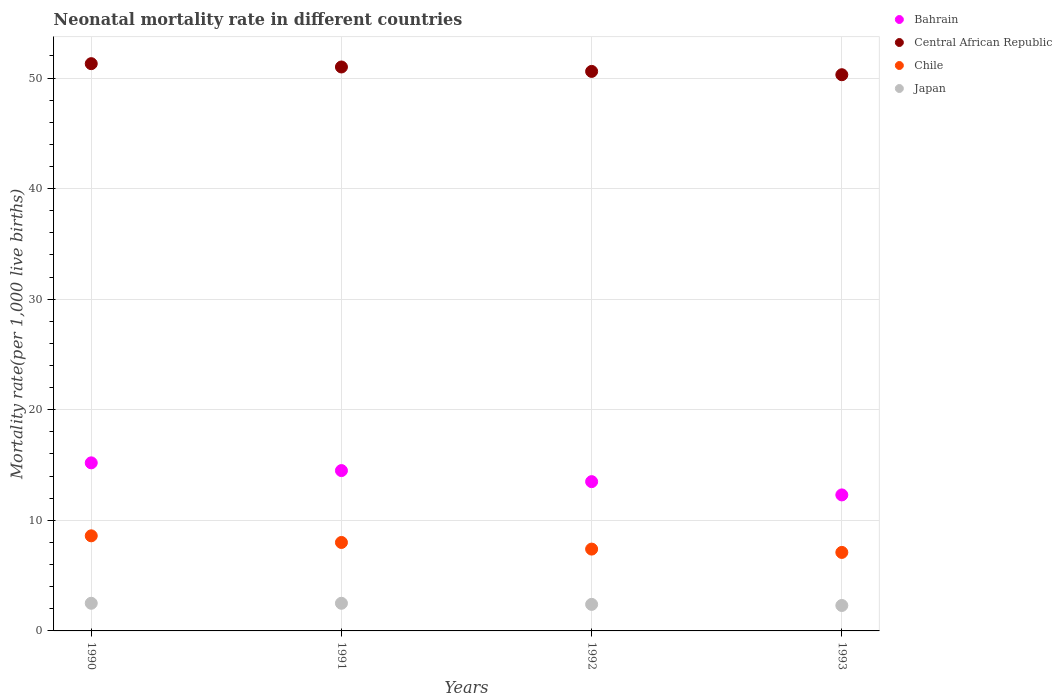How many different coloured dotlines are there?
Ensure brevity in your answer.  4. Is the number of dotlines equal to the number of legend labels?
Ensure brevity in your answer.  Yes. What is the neonatal mortality rate in Central African Republic in 1993?
Ensure brevity in your answer.  50.3. Across all years, what is the maximum neonatal mortality rate in Central African Republic?
Give a very brief answer. 51.3. Across all years, what is the minimum neonatal mortality rate in Japan?
Your response must be concise. 2.3. In which year was the neonatal mortality rate in Central African Republic maximum?
Provide a short and direct response. 1990. What is the total neonatal mortality rate in Bahrain in the graph?
Offer a terse response. 55.5. What is the difference between the neonatal mortality rate in Japan in 1992 and that in 1993?
Keep it short and to the point. 0.1. What is the difference between the neonatal mortality rate in Chile in 1993 and the neonatal mortality rate in Bahrain in 1992?
Give a very brief answer. -6.4. What is the average neonatal mortality rate in Chile per year?
Keep it short and to the point. 7.78. In how many years, is the neonatal mortality rate in Central African Republic greater than 40?
Your answer should be very brief. 4. What is the ratio of the neonatal mortality rate in Japan in 1992 to that in 1993?
Ensure brevity in your answer.  1.04. What is the difference between the highest and the lowest neonatal mortality rate in Central African Republic?
Give a very brief answer. 1. Is the sum of the neonatal mortality rate in Japan in 1991 and 1993 greater than the maximum neonatal mortality rate in Central African Republic across all years?
Make the answer very short. No. Does the neonatal mortality rate in Bahrain monotonically increase over the years?
Make the answer very short. No. Is the neonatal mortality rate in Chile strictly greater than the neonatal mortality rate in Central African Republic over the years?
Give a very brief answer. No. Is the neonatal mortality rate in Central African Republic strictly less than the neonatal mortality rate in Chile over the years?
Keep it short and to the point. No. How many dotlines are there?
Ensure brevity in your answer.  4. How many years are there in the graph?
Keep it short and to the point. 4. What is the difference between two consecutive major ticks on the Y-axis?
Your response must be concise. 10. Are the values on the major ticks of Y-axis written in scientific E-notation?
Your answer should be very brief. No. Does the graph contain any zero values?
Provide a succinct answer. No. How are the legend labels stacked?
Your answer should be very brief. Vertical. What is the title of the graph?
Your answer should be compact. Neonatal mortality rate in different countries. What is the label or title of the Y-axis?
Offer a terse response. Mortality rate(per 1,0 live births). What is the Mortality rate(per 1,000 live births) in Central African Republic in 1990?
Offer a terse response. 51.3. What is the Mortality rate(per 1,000 live births) in Chile in 1990?
Offer a very short reply. 8.6. What is the Mortality rate(per 1,000 live births) in Japan in 1990?
Keep it short and to the point. 2.5. What is the Mortality rate(per 1,000 live births) of Central African Republic in 1991?
Offer a terse response. 51. What is the Mortality rate(per 1,000 live births) in Chile in 1991?
Provide a short and direct response. 8. What is the Mortality rate(per 1,000 live births) in Japan in 1991?
Your answer should be compact. 2.5. What is the Mortality rate(per 1,000 live births) in Central African Republic in 1992?
Provide a short and direct response. 50.6. What is the Mortality rate(per 1,000 live births) in Bahrain in 1993?
Offer a very short reply. 12.3. What is the Mortality rate(per 1,000 live births) of Central African Republic in 1993?
Your answer should be very brief. 50.3. What is the Mortality rate(per 1,000 live births) in Japan in 1993?
Your answer should be compact. 2.3. Across all years, what is the maximum Mortality rate(per 1,000 live births) in Bahrain?
Offer a terse response. 15.2. Across all years, what is the maximum Mortality rate(per 1,000 live births) in Central African Republic?
Your response must be concise. 51.3. Across all years, what is the maximum Mortality rate(per 1,000 live births) in Chile?
Give a very brief answer. 8.6. Across all years, what is the minimum Mortality rate(per 1,000 live births) of Bahrain?
Make the answer very short. 12.3. Across all years, what is the minimum Mortality rate(per 1,000 live births) in Central African Republic?
Give a very brief answer. 50.3. Across all years, what is the minimum Mortality rate(per 1,000 live births) in Japan?
Offer a very short reply. 2.3. What is the total Mortality rate(per 1,000 live births) of Bahrain in the graph?
Your response must be concise. 55.5. What is the total Mortality rate(per 1,000 live births) in Central African Republic in the graph?
Your answer should be compact. 203.2. What is the total Mortality rate(per 1,000 live births) in Chile in the graph?
Keep it short and to the point. 31.1. What is the total Mortality rate(per 1,000 live births) of Japan in the graph?
Offer a very short reply. 9.7. What is the difference between the Mortality rate(per 1,000 live births) in Bahrain in 1990 and that in 1991?
Provide a short and direct response. 0.7. What is the difference between the Mortality rate(per 1,000 live births) of Central African Republic in 1990 and that in 1991?
Provide a short and direct response. 0.3. What is the difference between the Mortality rate(per 1,000 live births) of Japan in 1990 and that in 1991?
Your answer should be compact. 0. What is the difference between the Mortality rate(per 1,000 live births) of Central African Republic in 1990 and that in 1992?
Provide a short and direct response. 0.7. What is the difference between the Mortality rate(per 1,000 live births) of Chile in 1990 and that in 1992?
Make the answer very short. 1.2. What is the difference between the Mortality rate(per 1,000 live births) of Central African Republic in 1990 and that in 1993?
Offer a very short reply. 1. What is the difference between the Mortality rate(per 1,000 live births) in Japan in 1990 and that in 1993?
Give a very brief answer. 0.2. What is the difference between the Mortality rate(per 1,000 live births) of Central African Republic in 1991 and that in 1992?
Your answer should be very brief. 0.4. What is the difference between the Mortality rate(per 1,000 live births) in Chile in 1991 and that in 1992?
Ensure brevity in your answer.  0.6. What is the difference between the Mortality rate(per 1,000 live births) in Japan in 1991 and that in 1992?
Offer a very short reply. 0.1. What is the difference between the Mortality rate(per 1,000 live births) of Central African Republic in 1991 and that in 1993?
Offer a very short reply. 0.7. What is the difference between the Mortality rate(per 1,000 live births) in Japan in 1991 and that in 1993?
Ensure brevity in your answer.  0.2. What is the difference between the Mortality rate(per 1,000 live births) of Bahrain in 1992 and that in 1993?
Your response must be concise. 1.2. What is the difference between the Mortality rate(per 1,000 live births) in Chile in 1992 and that in 1993?
Your answer should be compact. 0.3. What is the difference between the Mortality rate(per 1,000 live births) of Bahrain in 1990 and the Mortality rate(per 1,000 live births) of Central African Republic in 1991?
Your answer should be compact. -35.8. What is the difference between the Mortality rate(per 1,000 live births) of Bahrain in 1990 and the Mortality rate(per 1,000 live births) of Chile in 1991?
Your answer should be compact. 7.2. What is the difference between the Mortality rate(per 1,000 live births) in Central African Republic in 1990 and the Mortality rate(per 1,000 live births) in Chile in 1991?
Ensure brevity in your answer.  43.3. What is the difference between the Mortality rate(per 1,000 live births) of Central African Republic in 1990 and the Mortality rate(per 1,000 live births) of Japan in 1991?
Give a very brief answer. 48.8. What is the difference between the Mortality rate(per 1,000 live births) in Bahrain in 1990 and the Mortality rate(per 1,000 live births) in Central African Republic in 1992?
Provide a short and direct response. -35.4. What is the difference between the Mortality rate(per 1,000 live births) in Bahrain in 1990 and the Mortality rate(per 1,000 live births) in Chile in 1992?
Provide a short and direct response. 7.8. What is the difference between the Mortality rate(per 1,000 live births) of Central African Republic in 1990 and the Mortality rate(per 1,000 live births) of Chile in 1992?
Offer a terse response. 43.9. What is the difference between the Mortality rate(per 1,000 live births) of Central African Republic in 1990 and the Mortality rate(per 1,000 live births) of Japan in 1992?
Keep it short and to the point. 48.9. What is the difference between the Mortality rate(per 1,000 live births) of Bahrain in 1990 and the Mortality rate(per 1,000 live births) of Central African Republic in 1993?
Ensure brevity in your answer.  -35.1. What is the difference between the Mortality rate(per 1,000 live births) in Bahrain in 1990 and the Mortality rate(per 1,000 live births) in Japan in 1993?
Ensure brevity in your answer.  12.9. What is the difference between the Mortality rate(per 1,000 live births) of Central African Republic in 1990 and the Mortality rate(per 1,000 live births) of Chile in 1993?
Offer a terse response. 44.2. What is the difference between the Mortality rate(per 1,000 live births) in Central African Republic in 1990 and the Mortality rate(per 1,000 live births) in Japan in 1993?
Your response must be concise. 49. What is the difference between the Mortality rate(per 1,000 live births) in Bahrain in 1991 and the Mortality rate(per 1,000 live births) in Central African Republic in 1992?
Offer a very short reply. -36.1. What is the difference between the Mortality rate(per 1,000 live births) of Central African Republic in 1991 and the Mortality rate(per 1,000 live births) of Chile in 1992?
Your answer should be compact. 43.6. What is the difference between the Mortality rate(per 1,000 live births) in Central African Republic in 1991 and the Mortality rate(per 1,000 live births) in Japan in 1992?
Your answer should be very brief. 48.6. What is the difference between the Mortality rate(per 1,000 live births) of Chile in 1991 and the Mortality rate(per 1,000 live births) of Japan in 1992?
Give a very brief answer. 5.6. What is the difference between the Mortality rate(per 1,000 live births) in Bahrain in 1991 and the Mortality rate(per 1,000 live births) in Central African Republic in 1993?
Your answer should be very brief. -35.8. What is the difference between the Mortality rate(per 1,000 live births) of Central African Republic in 1991 and the Mortality rate(per 1,000 live births) of Chile in 1993?
Offer a very short reply. 43.9. What is the difference between the Mortality rate(per 1,000 live births) in Central African Republic in 1991 and the Mortality rate(per 1,000 live births) in Japan in 1993?
Offer a terse response. 48.7. What is the difference between the Mortality rate(per 1,000 live births) in Bahrain in 1992 and the Mortality rate(per 1,000 live births) in Central African Republic in 1993?
Offer a terse response. -36.8. What is the difference between the Mortality rate(per 1,000 live births) in Bahrain in 1992 and the Mortality rate(per 1,000 live births) in Japan in 1993?
Provide a succinct answer. 11.2. What is the difference between the Mortality rate(per 1,000 live births) of Central African Republic in 1992 and the Mortality rate(per 1,000 live births) of Chile in 1993?
Provide a short and direct response. 43.5. What is the difference between the Mortality rate(per 1,000 live births) of Central African Republic in 1992 and the Mortality rate(per 1,000 live births) of Japan in 1993?
Provide a succinct answer. 48.3. What is the average Mortality rate(per 1,000 live births) in Bahrain per year?
Offer a terse response. 13.88. What is the average Mortality rate(per 1,000 live births) of Central African Republic per year?
Ensure brevity in your answer.  50.8. What is the average Mortality rate(per 1,000 live births) of Chile per year?
Offer a very short reply. 7.78. What is the average Mortality rate(per 1,000 live births) in Japan per year?
Offer a terse response. 2.42. In the year 1990, what is the difference between the Mortality rate(per 1,000 live births) in Bahrain and Mortality rate(per 1,000 live births) in Central African Republic?
Give a very brief answer. -36.1. In the year 1990, what is the difference between the Mortality rate(per 1,000 live births) of Central African Republic and Mortality rate(per 1,000 live births) of Chile?
Your response must be concise. 42.7. In the year 1990, what is the difference between the Mortality rate(per 1,000 live births) of Central African Republic and Mortality rate(per 1,000 live births) of Japan?
Offer a terse response. 48.8. In the year 1990, what is the difference between the Mortality rate(per 1,000 live births) of Chile and Mortality rate(per 1,000 live births) of Japan?
Provide a succinct answer. 6.1. In the year 1991, what is the difference between the Mortality rate(per 1,000 live births) in Bahrain and Mortality rate(per 1,000 live births) in Central African Republic?
Ensure brevity in your answer.  -36.5. In the year 1991, what is the difference between the Mortality rate(per 1,000 live births) in Central African Republic and Mortality rate(per 1,000 live births) in Japan?
Keep it short and to the point. 48.5. In the year 1992, what is the difference between the Mortality rate(per 1,000 live births) in Bahrain and Mortality rate(per 1,000 live births) in Central African Republic?
Ensure brevity in your answer.  -37.1. In the year 1992, what is the difference between the Mortality rate(per 1,000 live births) in Bahrain and Mortality rate(per 1,000 live births) in Chile?
Your answer should be very brief. 6.1. In the year 1992, what is the difference between the Mortality rate(per 1,000 live births) in Bahrain and Mortality rate(per 1,000 live births) in Japan?
Offer a terse response. 11.1. In the year 1992, what is the difference between the Mortality rate(per 1,000 live births) of Central African Republic and Mortality rate(per 1,000 live births) of Chile?
Give a very brief answer. 43.2. In the year 1992, what is the difference between the Mortality rate(per 1,000 live births) of Central African Republic and Mortality rate(per 1,000 live births) of Japan?
Make the answer very short. 48.2. In the year 1992, what is the difference between the Mortality rate(per 1,000 live births) in Chile and Mortality rate(per 1,000 live births) in Japan?
Offer a very short reply. 5. In the year 1993, what is the difference between the Mortality rate(per 1,000 live births) in Bahrain and Mortality rate(per 1,000 live births) in Central African Republic?
Keep it short and to the point. -38. In the year 1993, what is the difference between the Mortality rate(per 1,000 live births) of Bahrain and Mortality rate(per 1,000 live births) of Chile?
Make the answer very short. 5.2. In the year 1993, what is the difference between the Mortality rate(per 1,000 live births) in Bahrain and Mortality rate(per 1,000 live births) in Japan?
Offer a terse response. 10. In the year 1993, what is the difference between the Mortality rate(per 1,000 live births) in Central African Republic and Mortality rate(per 1,000 live births) in Chile?
Keep it short and to the point. 43.2. What is the ratio of the Mortality rate(per 1,000 live births) in Bahrain in 1990 to that in 1991?
Give a very brief answer. 1.05. What is the ratio of the Mortality rate(per 1,000 live births) in Central African Republic in 1990 to that in 1991?
Provide a short and direct response. 1.01. What is the ratio of the Mortality rate(per 1,000 live births) in Chile in 1990 to that in 1991?
Offer a very short reply. 1.07. What is the ratio of the Mortality rate(per 1,000 live births) of Japan in 1990 to that in 1991?
Your response must be concise. 1. What is the ratio of the Mortality rate(per 1,000 live births) in Bahrain in 1990 to that in 1992?
Offer a very short reply. 1.13. What is the ratio of the Mortality rate(per 1,000 live births) in Central African Republic in 1990 to that in 1992?
Give a very brief answer. 1.01. What is the ratio of the Mortality rate(per 1,000 live births) of Chile in 1990 to that in 1992?
Give a very brief answer. 1.16. What is the ratio of the Mortality rate(per 1,000 live births) in Japan in 1990 to that in 1992?
Offer a very short reply. 1.04. What is the ratio of the Mortality rate(per 1,000 live births) of Bahrain in 1990 to that in 1993?
Ensure brevity in your answer.  1.24. What is the ratio of the Mortality rate(per 1,000 live births) in Central African Republic in 1990 to that in 1993?
Your answer should be compact. 1.02. What is the ratio of the Mortality rate(per 1,000 live births) in Chile in 1990 to that in 1993?
Offer a very short reply. 1.21. What is the ratio of the Mortality rate(per 1,000 live births) of Japan in 1990 to that in 1993?
Offer a very short reply. 1.09. What is the ratio of the Mortality rate(per 1,000 live births) of Bahrain in 1991 to that in 1992?
Keep it short and to the point. 1.07. What is the ratio of the Mortality rate(per 1,000 live births) in Central African Republic in 1991 to that in 1992?
Ensure brevity in your answer.  1.01. What is the ratio of the Mortality rate(per 1,000 live births) in Chile in 1991 to that in 1992?
Keep it short and to the point. 1.08. What is the ratio of the Mortality rate(per 1,000 live births) in Japan in 1991 to that in 1992?
Your answer should be very brief. 1.04. What is the ratio of the Mortality rate(per 1,000 live births) in Bahrain in 1991 to that in 1993?
Your response must be concise. 1.18. What is the ratio of the Mortality rate(per 1,000 live births) of Central African Republic in 1991 to that in 1993?
Provide a succinct answer. 1.01. What is the ratio of the Mortality rate(per 1,000 live births) in Chile in 1991 to that in 1993?
Provide a short and direct response. 1.13. What is the ratio of the Mortality rate(per 1,000 live births) in Japan in 1991 to that in 1993?
Provide a short and direct response. 1.09. What is the ratio of the Mortality rate(per 1,000 live births) of Bahrain in 1992 to that in 1993?
Provide a succinct answer. 1.1. What is the ratio of the Mortality rate(per 1,000 live births) of Chile in 1992 to that in 1993?
Make the answer very short. 1.04. What is the ratio of the Mortality rate(per 1,000 live births) of Japan in 1992 to that in 1993?
Give a very brief answer. 1.04. What is the difference between the highest and the second highest Mortality rate(per 1,000 live births) of Bahrain?
Your answer should be very brief. 0.7. What is the difference between the highest and the second highest Mortality rate(per 1,000 live births) in Central African Republic?
Your response must be concise. 0.3. What is the difference between the highest and the second highest Mortality rate(per 1,000 live births) of Chile?
Provide a short and direct response. 0.6. What is the difference between the highest and the lowest Mortality rate(per 1,000 live births) in Bahrain?
Provide a succinct answer. 2.9. What is the difference between the highest and the lowest Mortality rate(per 1,000 live births) of Japan?
Give a very brief answer. 0.2. 